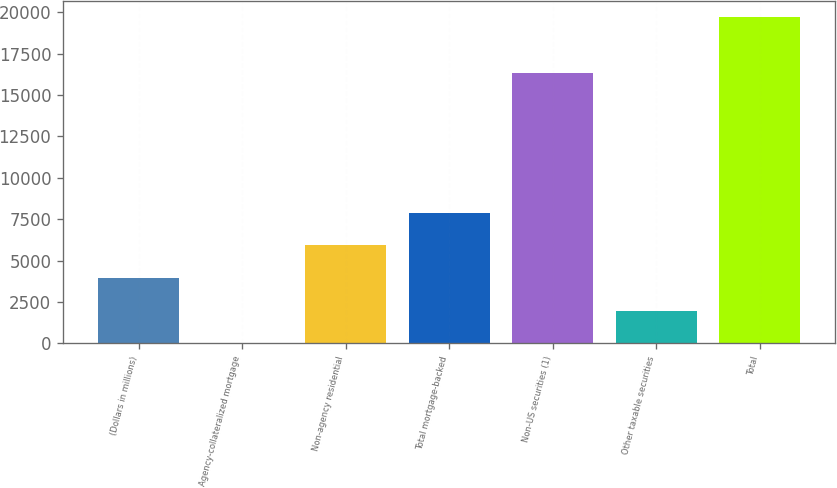Convert chart to OTSL. <chart><loc_0><loc_0><loc_500><loc_500><bar_chart><fcel>(Dollars in millions)<fcel>Agency-collateralized mortgage<fcel>Non-agency residential<fcel>Total mortgage-backed<fcel>Non-US securities (1)<fcel>Other taxable securities<fcel>Total<nl><fcel>3948<fcel>5<fcel>5919.5<fcel>7891<fcel>16336<fcel>1976.5<fcel>19720<nl></chart> 